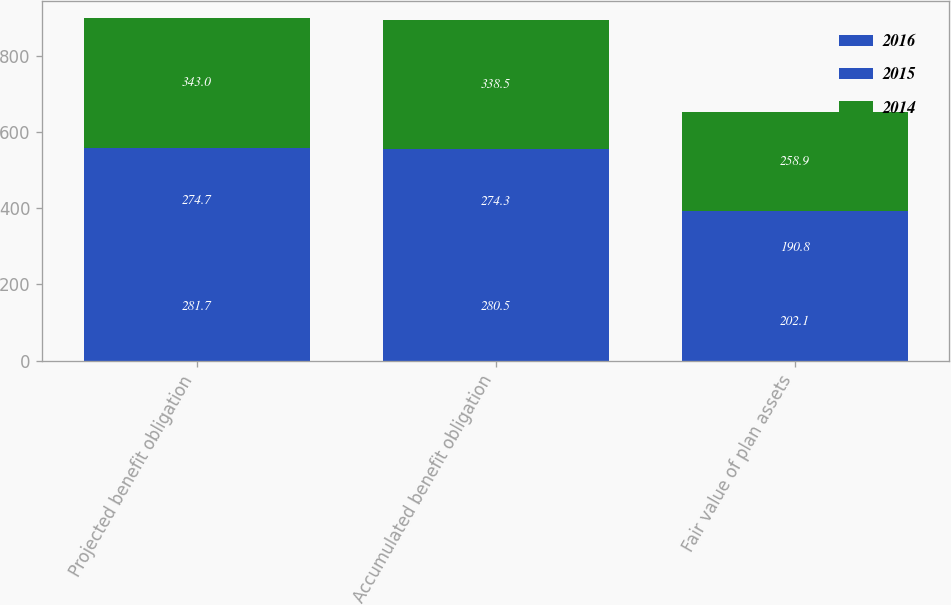<chart> <loc_0><loc_0><loc_500><loc_500><stacked_bar_chart><ecel><fcel>Projected benefit obligation<fcel>Accumulated benefit obligation<fcel>Fair value of plan assets<nl><fcel>2016<fcel>281.7<fcel>280.5<fcel>202.1<nl><fcel>2015<fcel>274.7<fcel>274.3<fcel>190.8<nl><fcel>2014<fcel>343<fcel>338.5<fcel>258.9<nl></chart> 